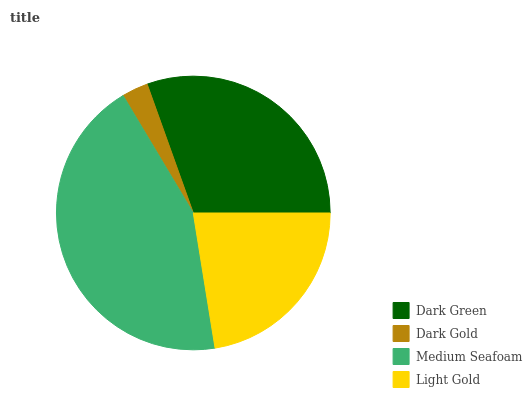Is Dark Gold the minimum?
Answer yes or no. Yes. Is Medium Seafoam the maximum?
Answer yes or no. Yes. Is Medium Seafoam the minimum?
Answer yes or no. No. Is Dark Gold the maximum?
Answer yes or no. No. Is Medium Seafoam greater than Dark Gold?
Answer yes or no. Yes. Is Dark Gold less than Medium Seafoam?
Answer yes or no. Yes. Is Dark Gold greater than Medium Seafoam?
Answer yes or no. No. Is Medium Seafoam less than Dark Gold?
Answer yes or no. No. Is Dark Green the high median?
Answer yes or no. Yes. Is Light Gold the low median?
Answer yes or no. Yes. Is Medium Seafoam the high median?
Answer yes or no. No. Is Dark Gold the low median?
Answer yes or no. No. 